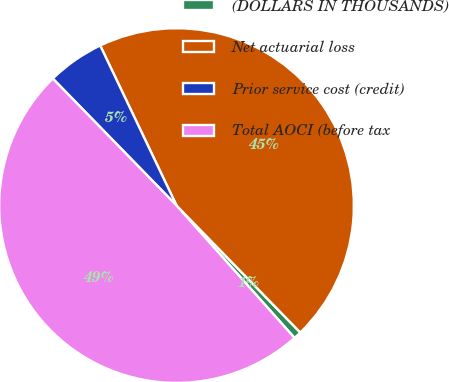Convert chart to OTSL. <chart><loc_0><loc_0><loc_500><loc_500><pie_chart><fcel>(DOLLARS IN THOUSANDS)<fcel>Net actuarial loss<fcel>Prior service cost (credit)<fcel>Total AOCI (before tax<nl><fcel>0.71%<fcel>44.79%<fcel>5.21%<fcel>49.29%<nl></chart> 